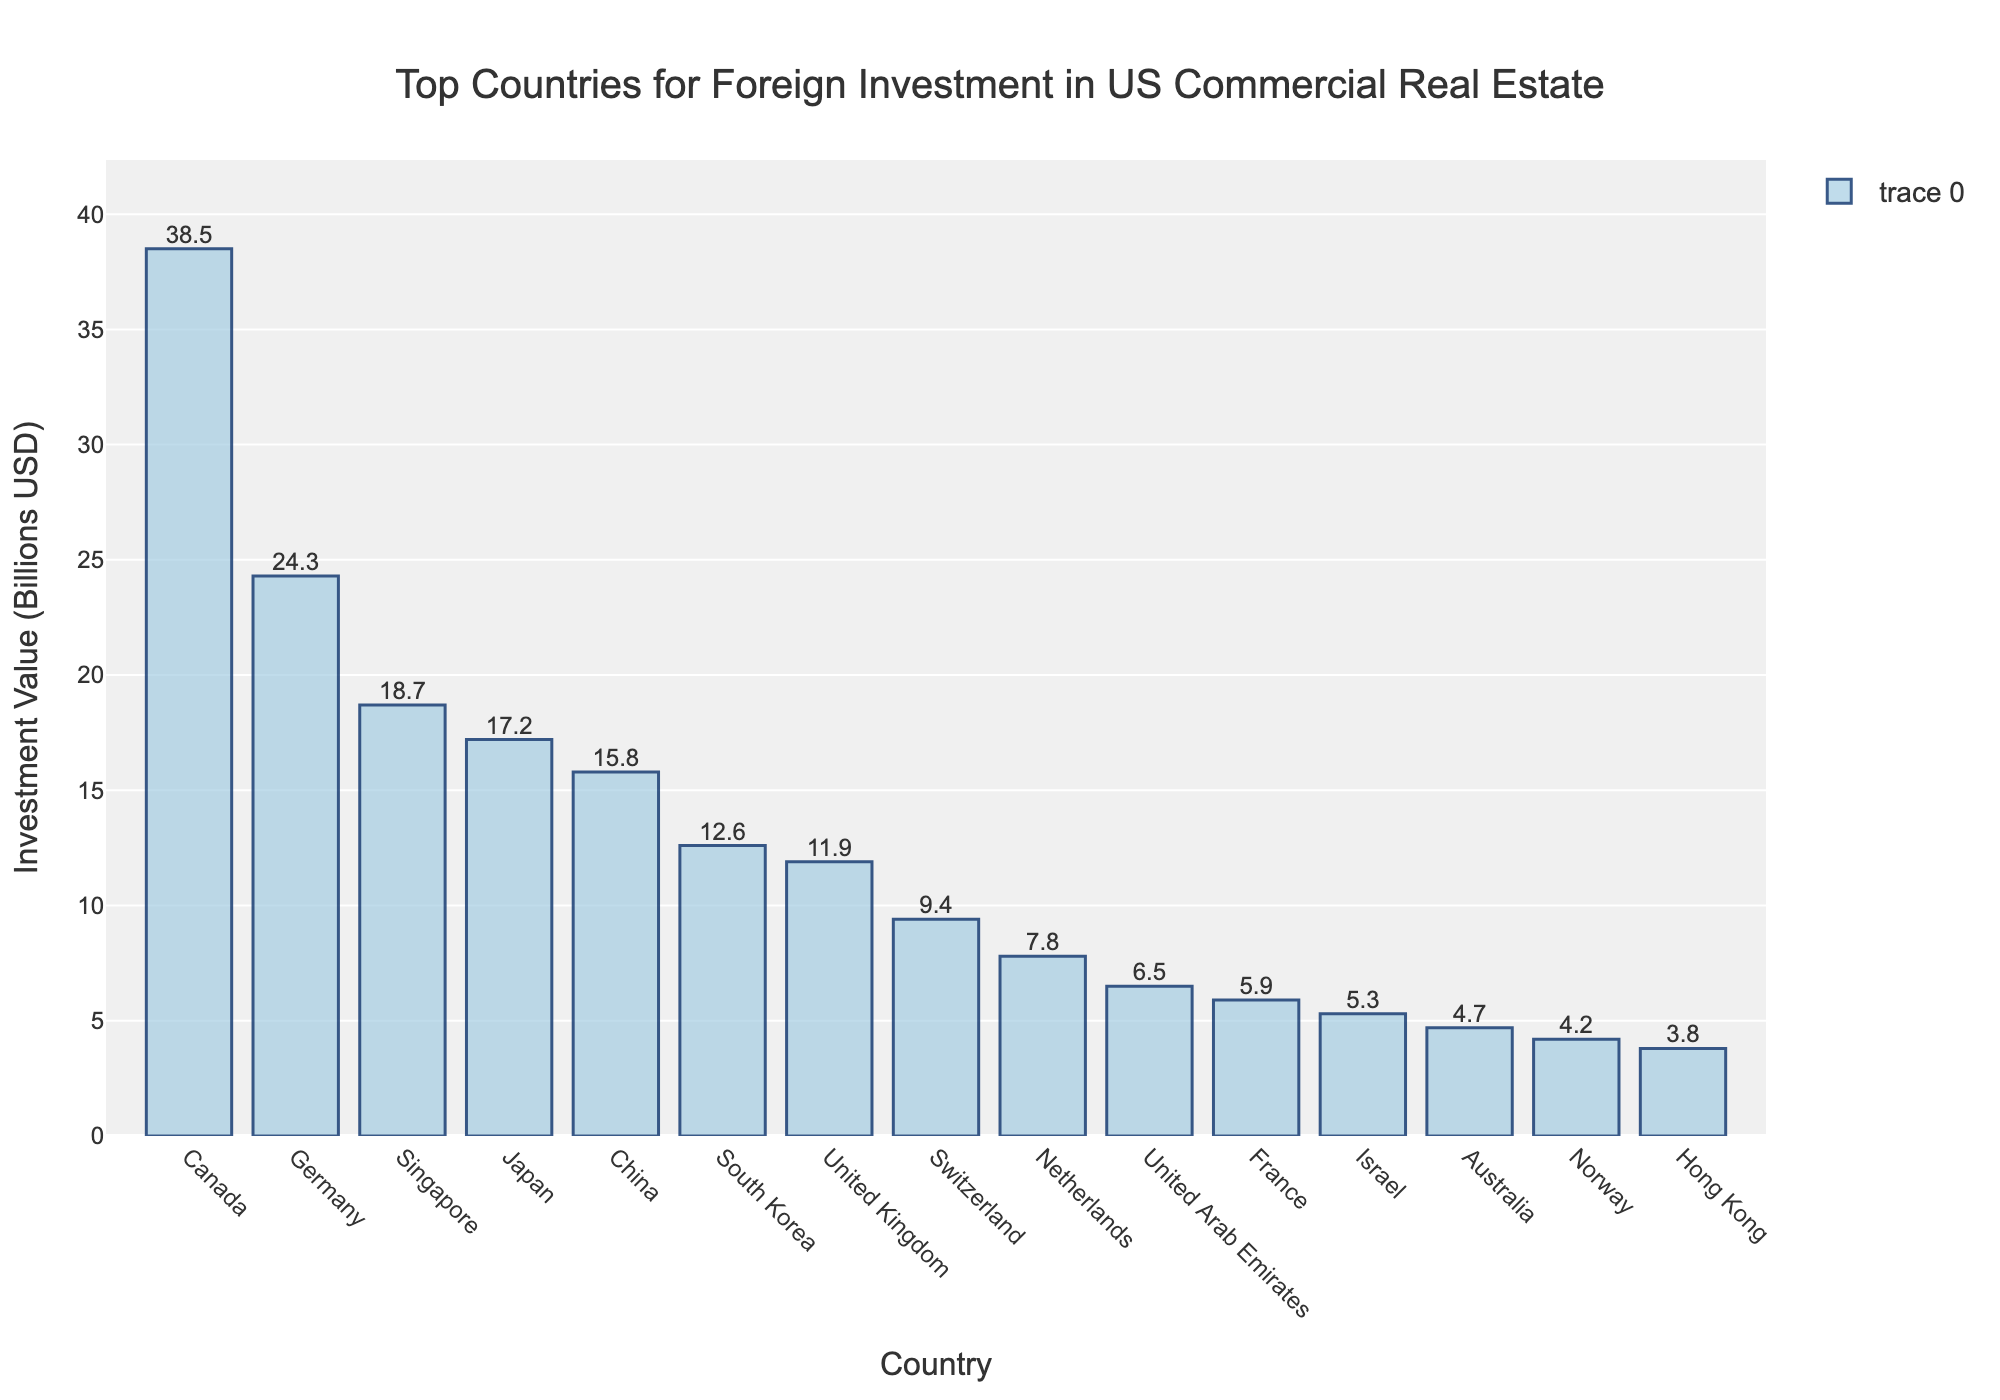What is the total investment value from the top 10 countries? Sum the investment values of the top 10 countries: 38.5 (Canada) + 24.3 (Germany) + 18.7 (Singapore) + 17.2 (Japan) + 15.8 (China) + 12.6 (South Korea) + 11.9 (United Kingdom) + 9.4 (Switzerland) + 7.8 (Netherlands) + 6.5 (United Arab Emirates) = 162.7 billion USD
Answer: 162.7 billion USD Which country has the highest investment value in US commercial real estate? Observe the bar with the greatest height, which belongs to Canada with 38.5 billion USD.
Answer: Canada What is the combined investment value of Japan and Germany? Add the investment values of Japan (17.2 billion USD) and Germany (24.3 billion USD): 17.2 + 24.3.
Answer: 41.5 billion USD How much more does Canada invest compared to the United Kingdom? Subtract the investment value of the United Kingdom (11.9 billion USD) from Canada's (38.5 billion USD): 38.5 - 11.9.
Answer: 26.6 billion USD Which countries invest less than 10 billion USD? Identify the bars corresponding to countries with investment values under 10 billion USD: Switzerland (9.4), Netherlands (7.8), and United Arab Emirates (6.5).
Answer: Switzerland, Netherlands, United Arab Emirates What is the average investment value of the countries listed? Calculate the average investment value by summing the values and dividing by the number of countries: (38.5 + 24.3 + 18.7 + 17.2 + 15.8 + 12.6 + 11.9 + 9.4 + 7.8 + 6.5) / 10 = 162.7 / 10.
Answer: 16.27 billion USD Rank the countries by their investment value from highest to lowest. List the countries in order of the height of their bars, from tallest to shortest: Canada, Germany, Singapore, Japan, China, South Korea, United Kingdom, Switzerland, Netherlands, United Arab Emirates.
Answer: Canada, Germany, Singapore, Japan, China, South Korea, United Kingdom, Switzerland, Netherlands, United Arab Emirates What is the difference in investment values between the third and fourth highest investing countries? Subtract the investment value of the fourth highest country (Japan, 17.2 billion USD) from the third highest (Singapore, 18.7 billion USD): 18.7 - 17.2.
Answer: 1.5 billion USD 